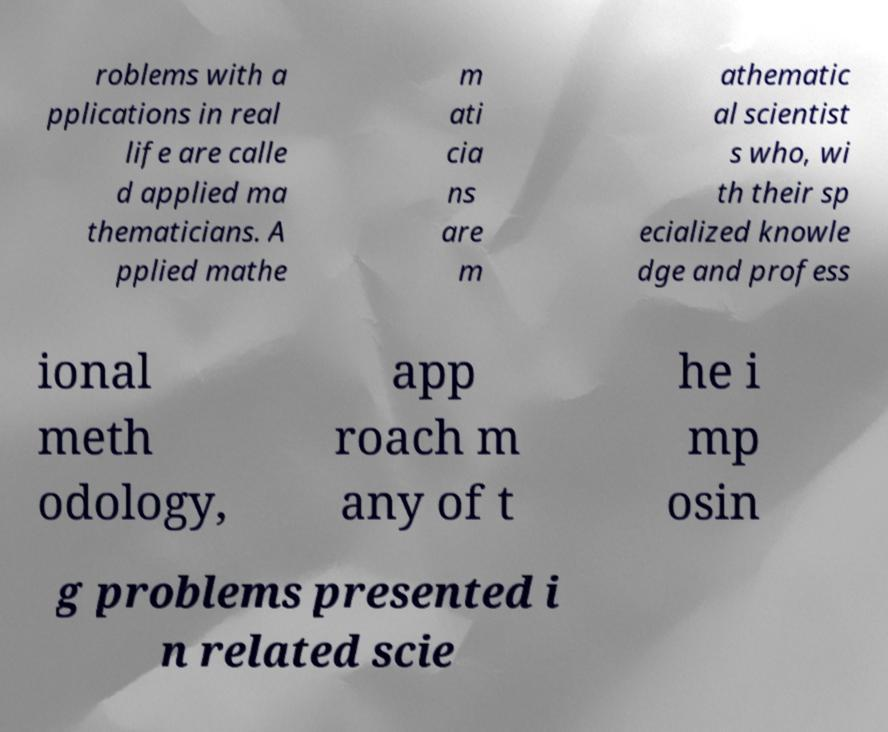Could you assist in decoding the text presented in this image and type it out clearly? roblems with a pplications in real life are calle d applied ma thematicians. A pplied mathe m ati cia ns are m athematic al scientist s who, wi th their sp ecialized knowle dge and profess ional meth odology, app roach m any of t he i mp osin g problems presented i n related scie 